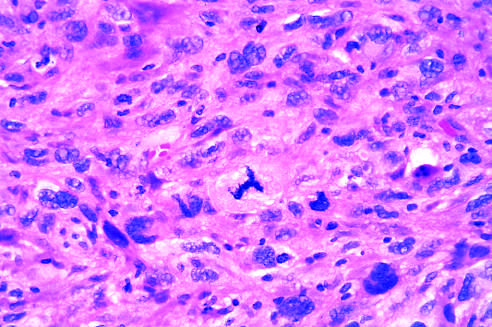does the prominent cell in the center field have an abnormal tripolar spindle?
Answer the question using a single word or phrase. Yes 